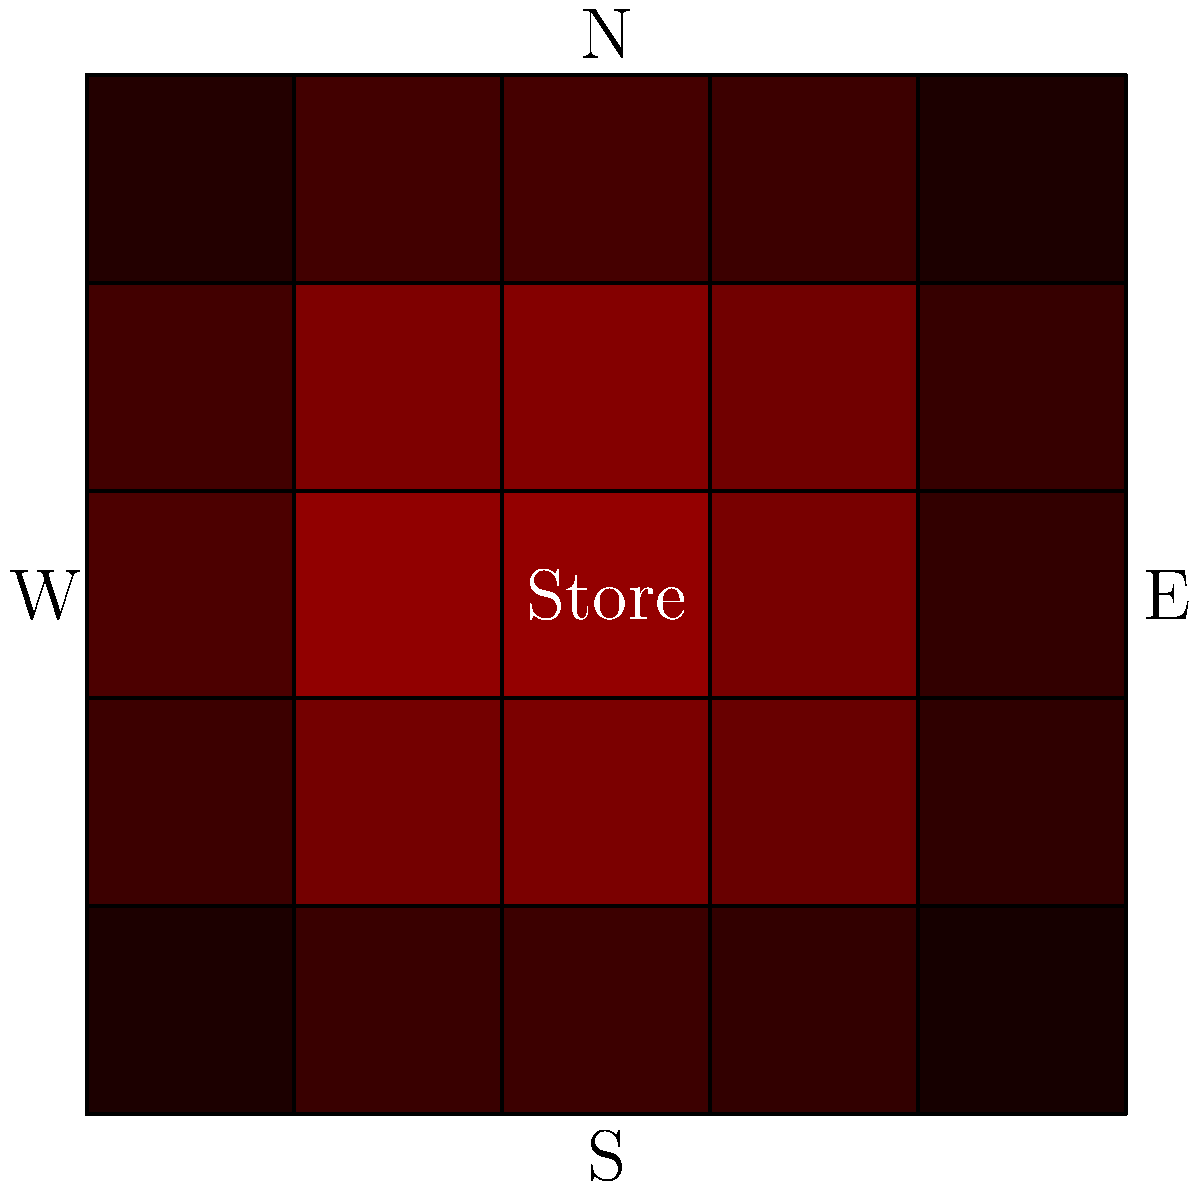Based on the crime heat map shown, which direction from the store has the highest risk of criminal activity? Assume darker red indicates higher crime rates. To determine the direction with the highest risk of criminal activity, we need to analyze the heat map:

1. Observe that the heat map uses shades of red to indicate crime rates, with darker red representing higher crime rates.

2. The store is located at the center of the map.

3. Examine the colors in each direction from the store:
   - North: Medium to light red
   - South: Light red
   - East: Dark red
   - West: Medium red

4. Compare the intensity of red in each direction:
   - The darkest red appears to be in the eastern direction.
   - The northeastern quadrant also shows a concentration of darker red.

5. Consider the gradient of color change:
   - The red intensifies as we move from the center towards the east.

6. Evaluate the overall pattern:
   - The eastern side of the map consistently shows darker shades of red compared to other directions.

Based on this analysis, we can conclude that the direction with the highest risk of criminal activity is east of the store.
Answer: East 